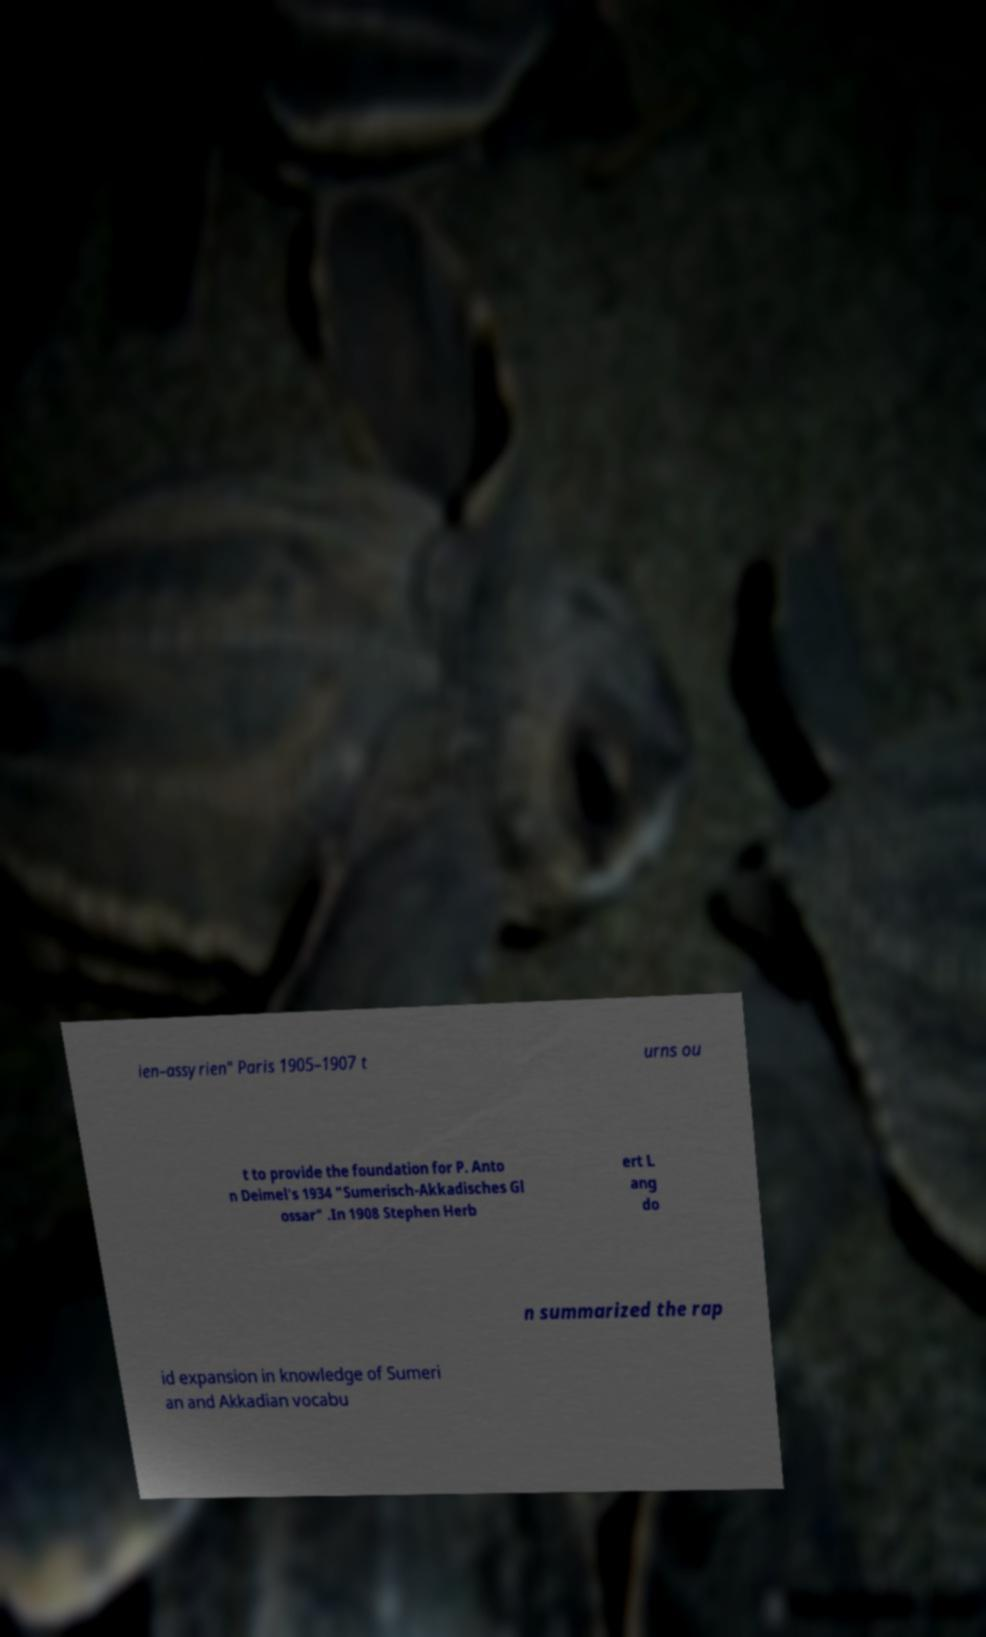For documentation purposes, I need the text within this image transcribed. Could you provide that? ien–assyrien" Paris 1905–1907 t urns ou t to provide the foundation for P. Anto n Deimel's 1934 "Sumerisch-Akkadisches Gl ossar" .In 1908 Stephen Herb ert L ang do n summarized the rap id expansion in knowledge of Sumeri an and Akkadian vocabu 